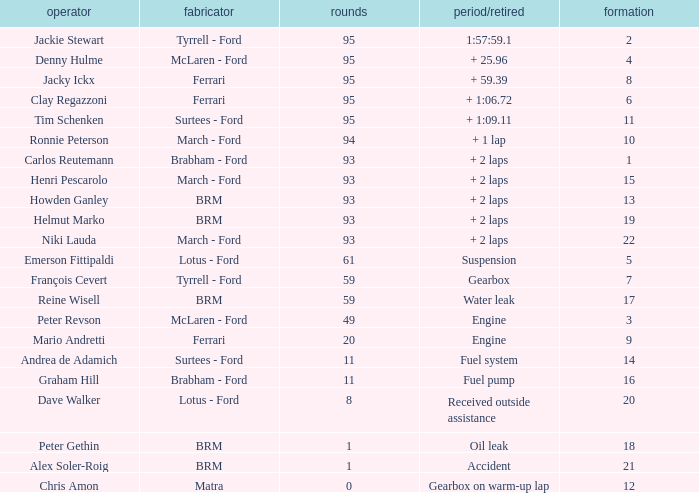Which grid has less than 11 laps, and a Time/Retired of accident? 21.0. 